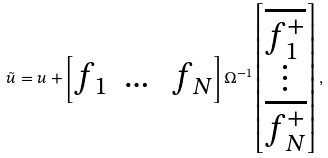Convert formula to latex. <formula><loc_0><loc_0><loc_500><loc_500>\tilde { u } = u + \begin{bmatrix} f _ { 1 } & \dots & f _ { N } \end{bmatrix} \Omega ^ { - 1 } \begin{bmatrix} \overline { f _ { 1 } ^ { + } } \\ \vdots \\ \overline { f _ { N } ^ { + } } \end{bmatrix} ,</formula> 